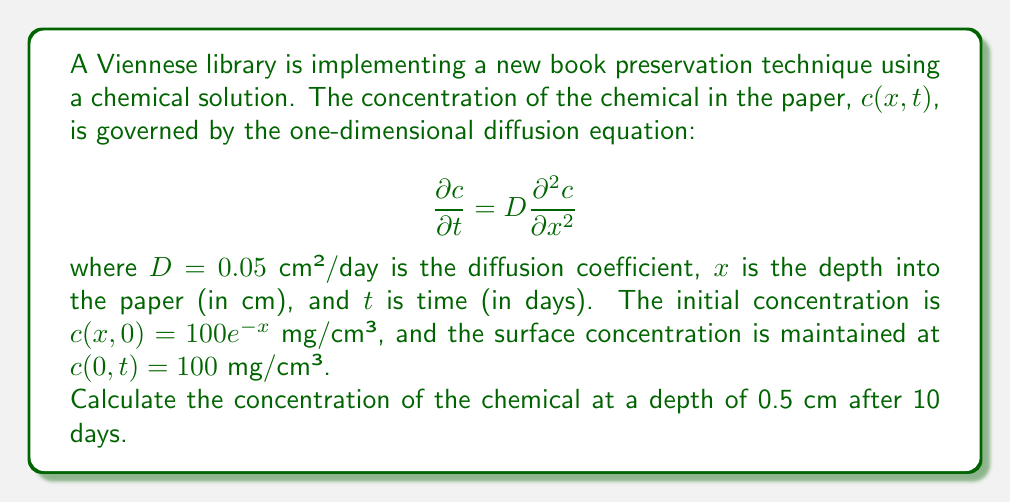Could you help me with this problem? To solve this problem, we can use the method of separation of variables:

1) Assume a solution of the form $c(x,t) = X(x)T(t)$.

2) Substituting into the diffusion equation:

   $$X(x)\frac{dT}{dt} = DT(t)\frac{d^2X}{dx^2}$$

3) Separating variables:

   $$\frac{1}{DT}\frac{dT}{dt} = \frac{1}{X}\frac{d^2X}{dx^2} = -\lambda^2$$

4) This leads to two ODEs:
   
   $$\frac{dT}{dt} + \lambda^2DT = 0$$
   $$\frac{d^2X}{dx^2} + \lambda^2X = 0$$

5) The general solution is:

   $$c(x,t) = \sum_{n=1}^{\infty} A_n \sin(\lambda_n x)e^{-D\lambda_n^2t}$$

6) Given the boundary condition $c(0,t) = 100$, we need to add a constant term:

   $$c(x,t) = 100 + \sum_{n=1}^{\infty} A_n \sin(\lambda_n x)e^{-D\lambda_n^2t}$$

7) The initial condition $c(x,0) = 100e^{-x}$ gives:

   $$100e^{-x} = 100 + \sum_{n=1}^{\infty} A_n \sin(\lambda_n x)$$

8) This is a Fourier sine series for $100(e^{-x} - 1)$. The coefficients are:

   $$A_n = \frac{200\lambda_n}{1 + \lambda_n^2}$$

   where $\lambda_n = \frac{(2n-1)\pi}{2L}$ and $L$ is a large value (e.g., 10).

9) The solution is:

   $$c(x,t) = 100 + \sum_{n=1}^{\infty} \frac{200\lambda_n}{1 + \lambda_n^2} \sin(\lambda_n x)e^{-D\lambda_n^2t}$$

10) For $x = 0.5$ cm and $t = 10$ days, we can compute this sum numerically, truncating after a sufficient number of terms.
Answer: Using numerical computation with 100 terms in the series, the concentration at $x = 0.5$ cm after 10 days is approximately 73.86 mg/cm³. 